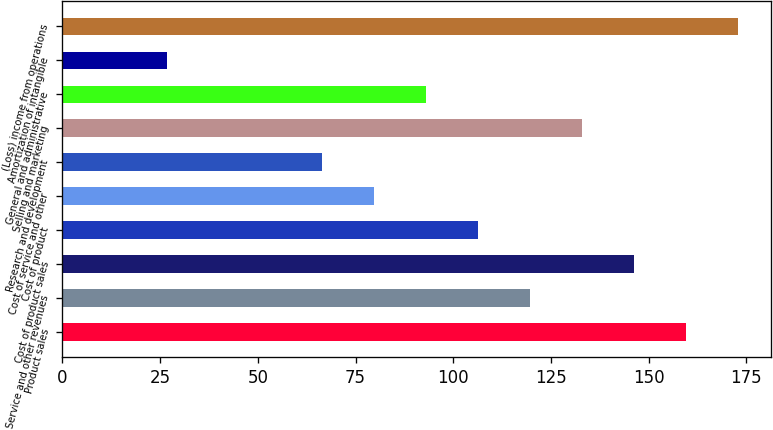Convert chart. <chart><loc_0><loc_0><loc_500><loc_500><bar_chart><fcel>Product sales<fcel>Service and other revenues<fcel>Cost of product sales<fcel>Cost of product<fcel>Cost of service and other<fcel>Research and development<fcel>Selling and marketing<fcel>General and administrative<fcel>Amortization of intangible<fcel>(Loss) income from operations<nl><fcel>159.46<fcel>119.62<fcel>146.18<fcel>106.34<fcel>79.78<fcel>66.5<fcel>132.9<fcel>93.06<fcel>26.66<fcel>172.74<nl></chart> 